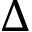<formula> <loc_0><loc_0><loc_500><loc_500>\Delta</formula> 